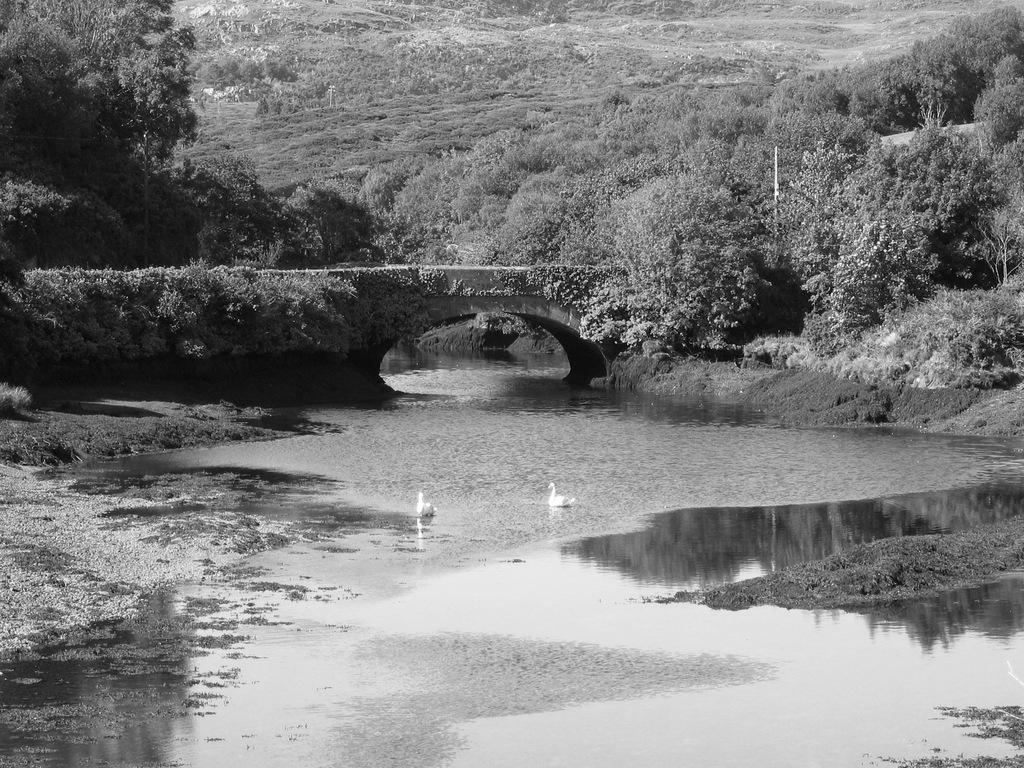In one or two sentences, can you explain what this image depicts? In this image we can see two birds on the water, there is bridge, few plants and trees in the background. 